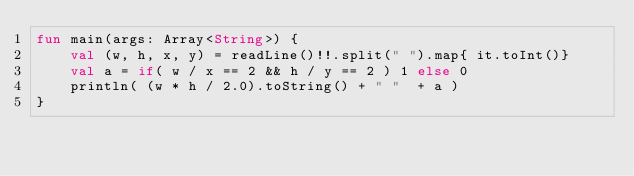<code> <loc_0><loc_0><loc_500><loc_500><_Kotlin_>fun main(args: Array<String>) {
    val (w, h, x, y) = readLine()!!.split(" ").map{ it.toInt()}
    val a = if( w / x == 2 && h / y == 2 ) 1 else 0
    println( (w * h / 2.0).toString() + " "  + a )
}
</code> 